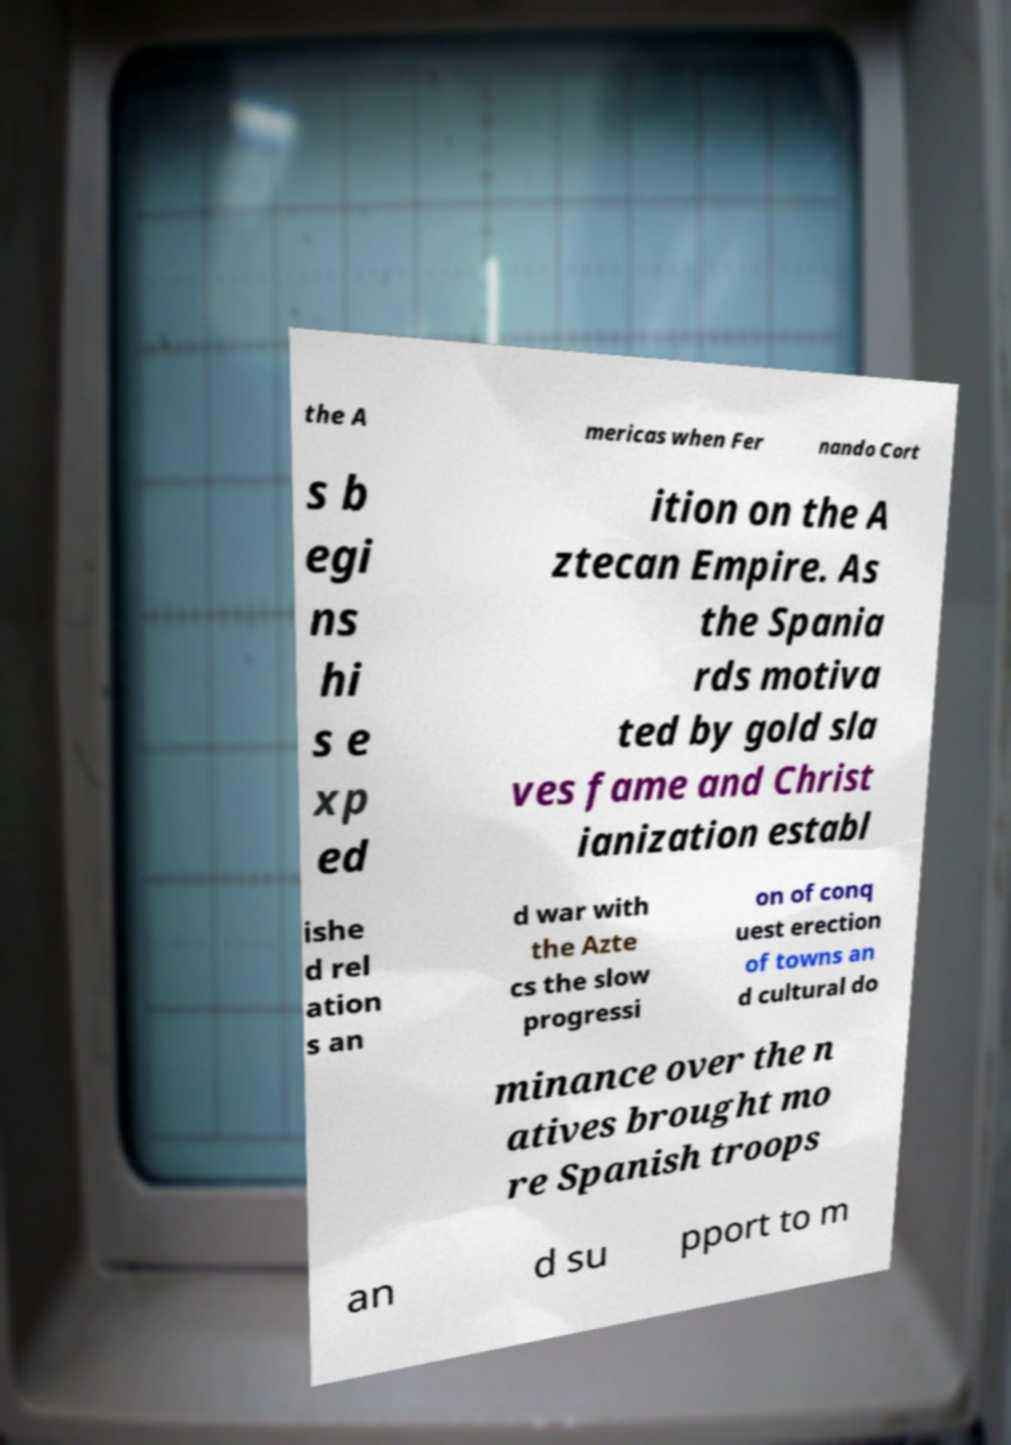What messages or text are displayed in this image? I need them in a readable, typed format. the A mericas when Fer nando Cort s b egi ns hi s e xp ed ition on the A ztecan Empire. As the Spania rds motiva ted by gold sla ves fame and Christ ianization establ ishe d rel ation s an d war with the Azte cs the slow progressi on of conq uest erection of towns an d cultural do minance over the n atives brought mo re Spanish troops an d su pport to m 